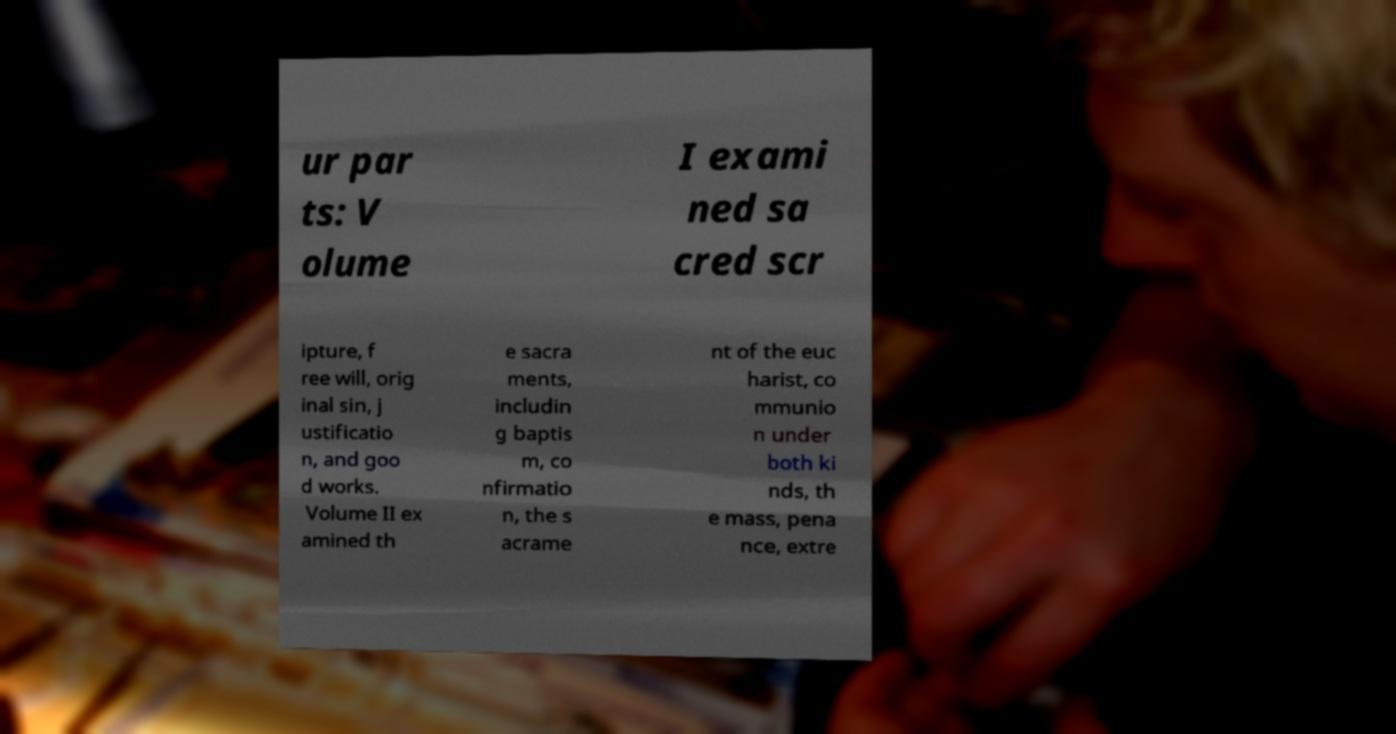I need the written content from this picture converted into text. Can you do that? ur par ts: V olume I exami ned sa cred scr ipture, f ree will, orig inal sin, j ustificatio n, and goo d works. Volume II ex amined th e sacra ments, includin g baptis m, co nfirmatio n, the s acrame nt of the euc harist, co mmunio n under both ki nds, th e mass, pena nce, extre 